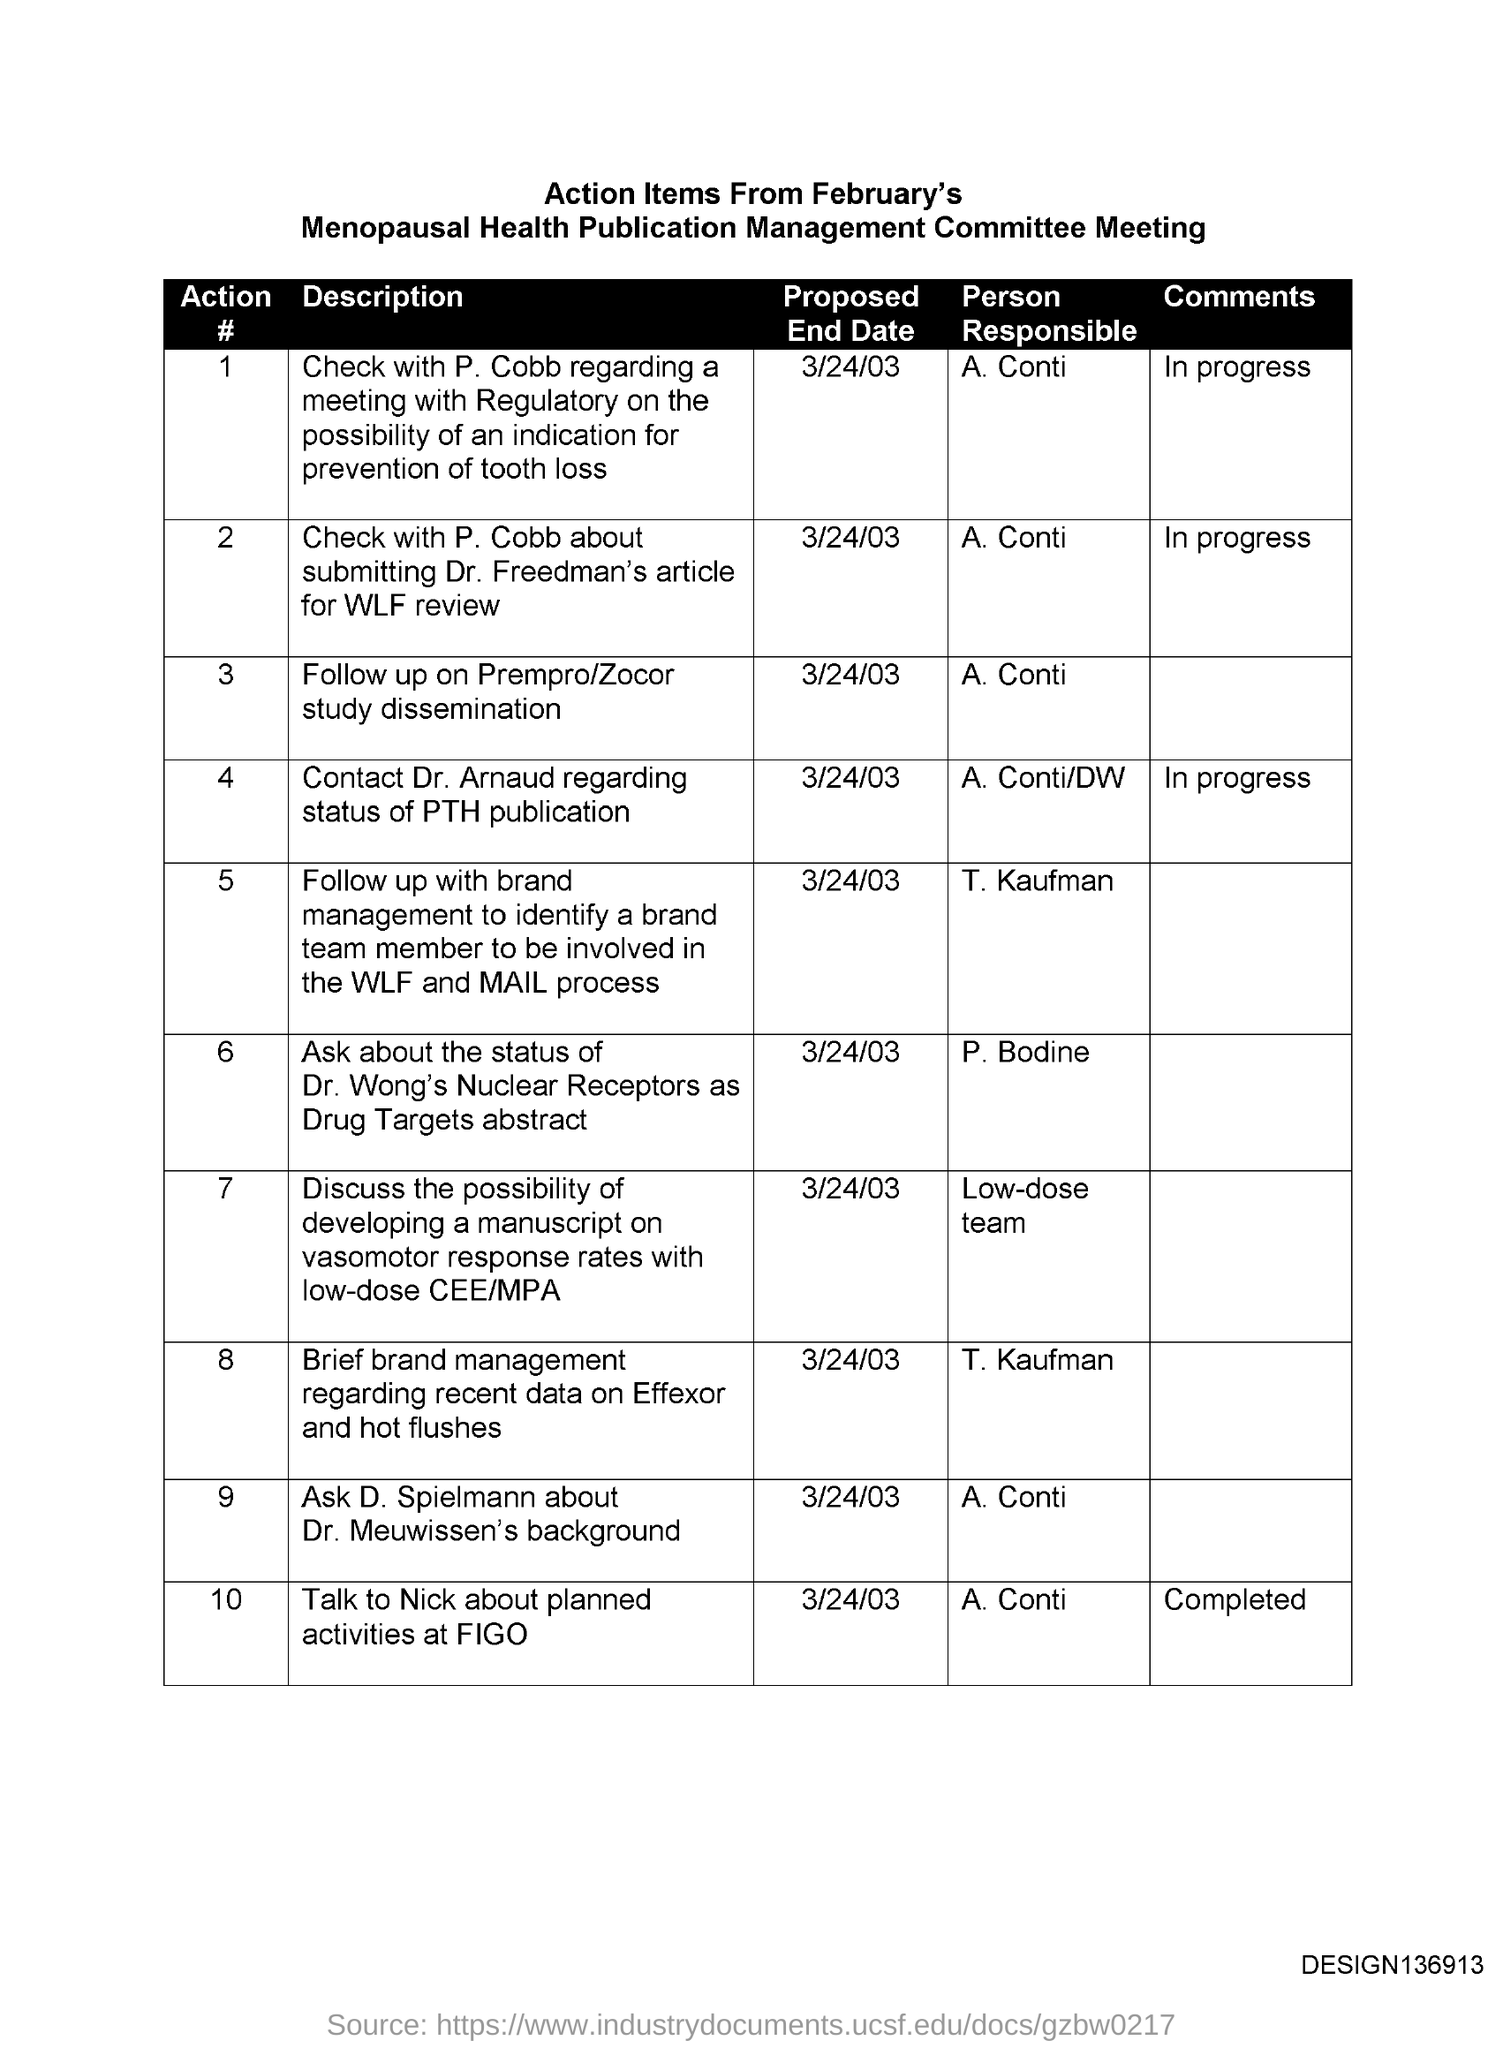What is the Proposed End date for Action # 1?
Your response must be concise. 3/24/03. What is the Proposed End date for Action # 2?
Your answer should be very brief. 3/24/03. What is the Proposed End date for Action # 3?
Offer a terse response. 3/24/03. What is the Proposed End date for Action # 4?
Offer a terse response. 3/24/03. What is the Proposed End date for Action # 5?
Offer a very short reply. 3/24/03. 